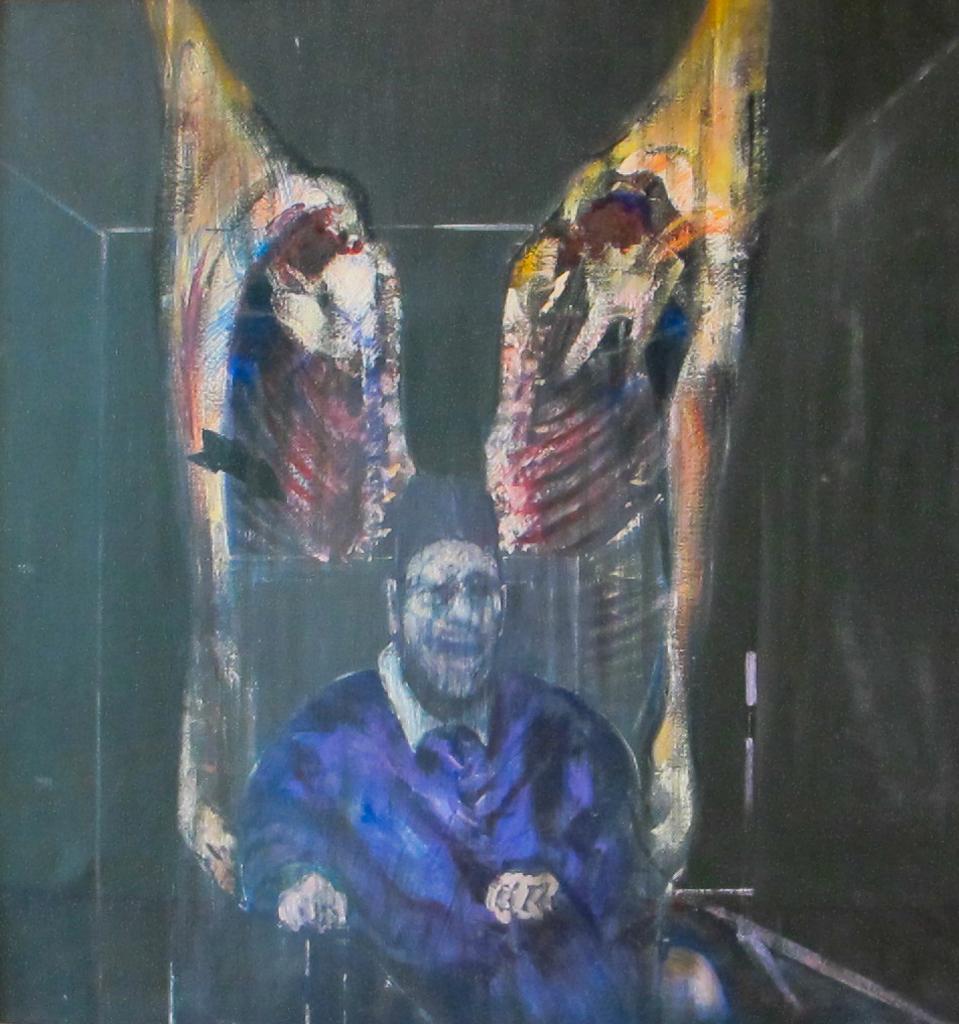Could you give a brief overview of what you see in this image? In this image there is a painting. In the painting there is a man sitting on a chair. 